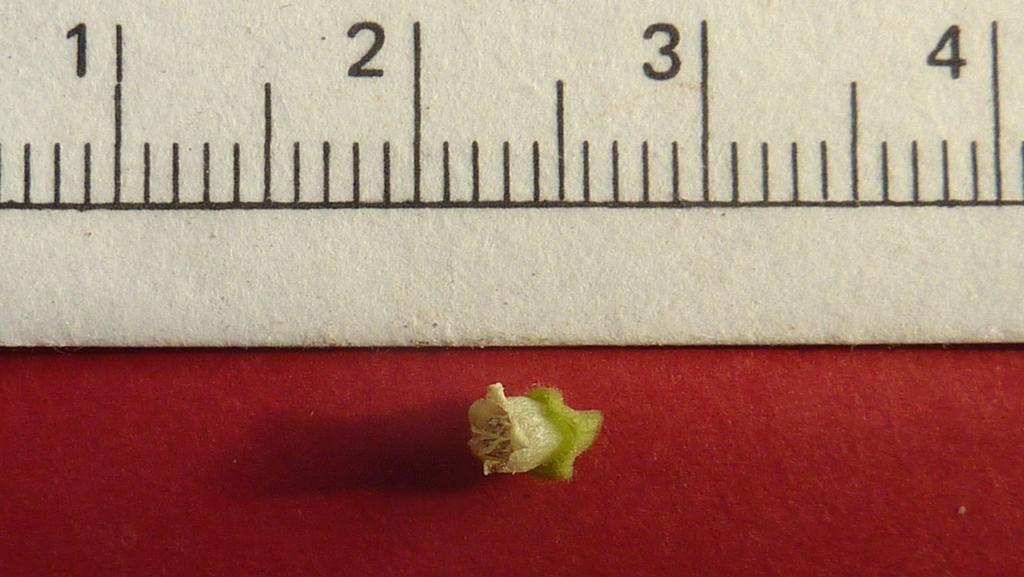What is the measurement of the little flower?
Make the answer very short. .5. What is the max measurement possible?
Make the answer very short. 4. 